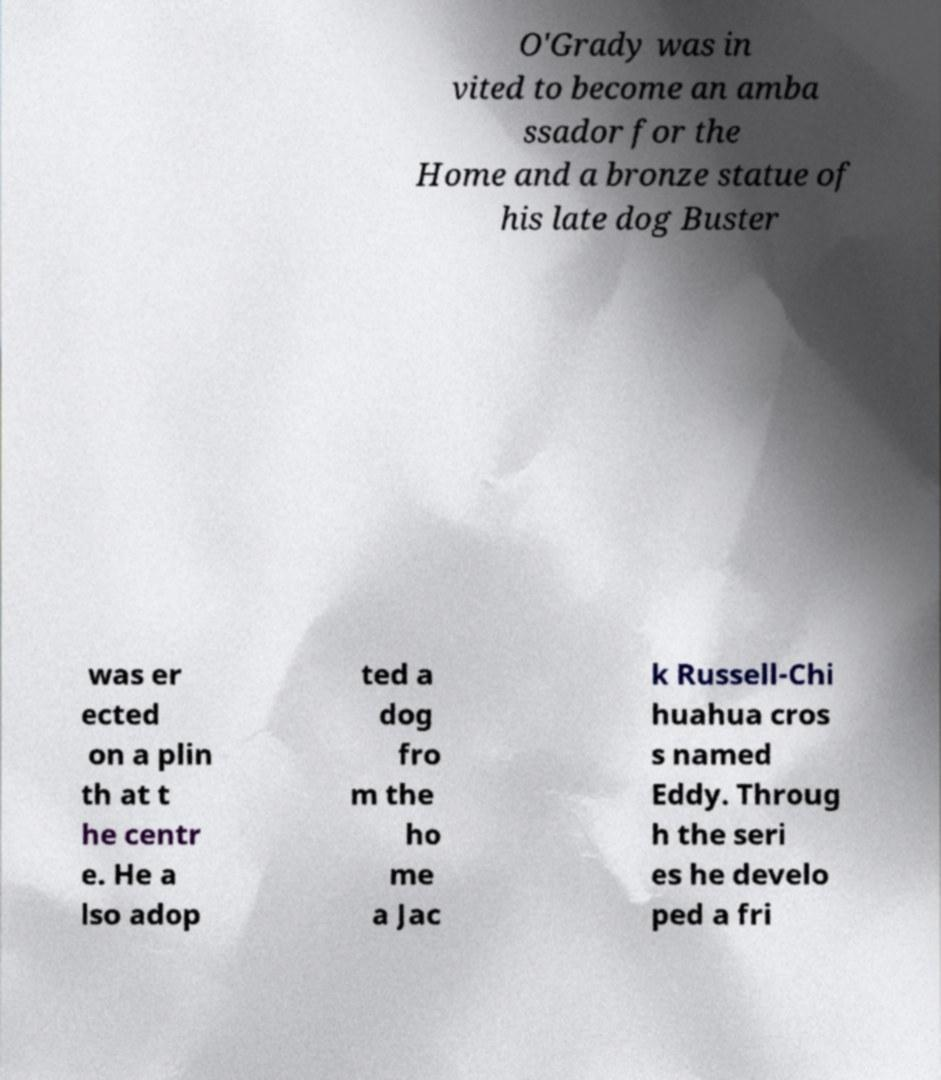Could you extract and type out the text from this image? O'Grady was in vited to become an amba ssador for the Home and a bronze statue of his late dog Buster was er ected on a plin th at t he centr e. He a lso adop ted a dog fro m the ho me a Jac k Russell-Chi huahua cros s named Eddy. Throug h the seri es he develo ped a fri 